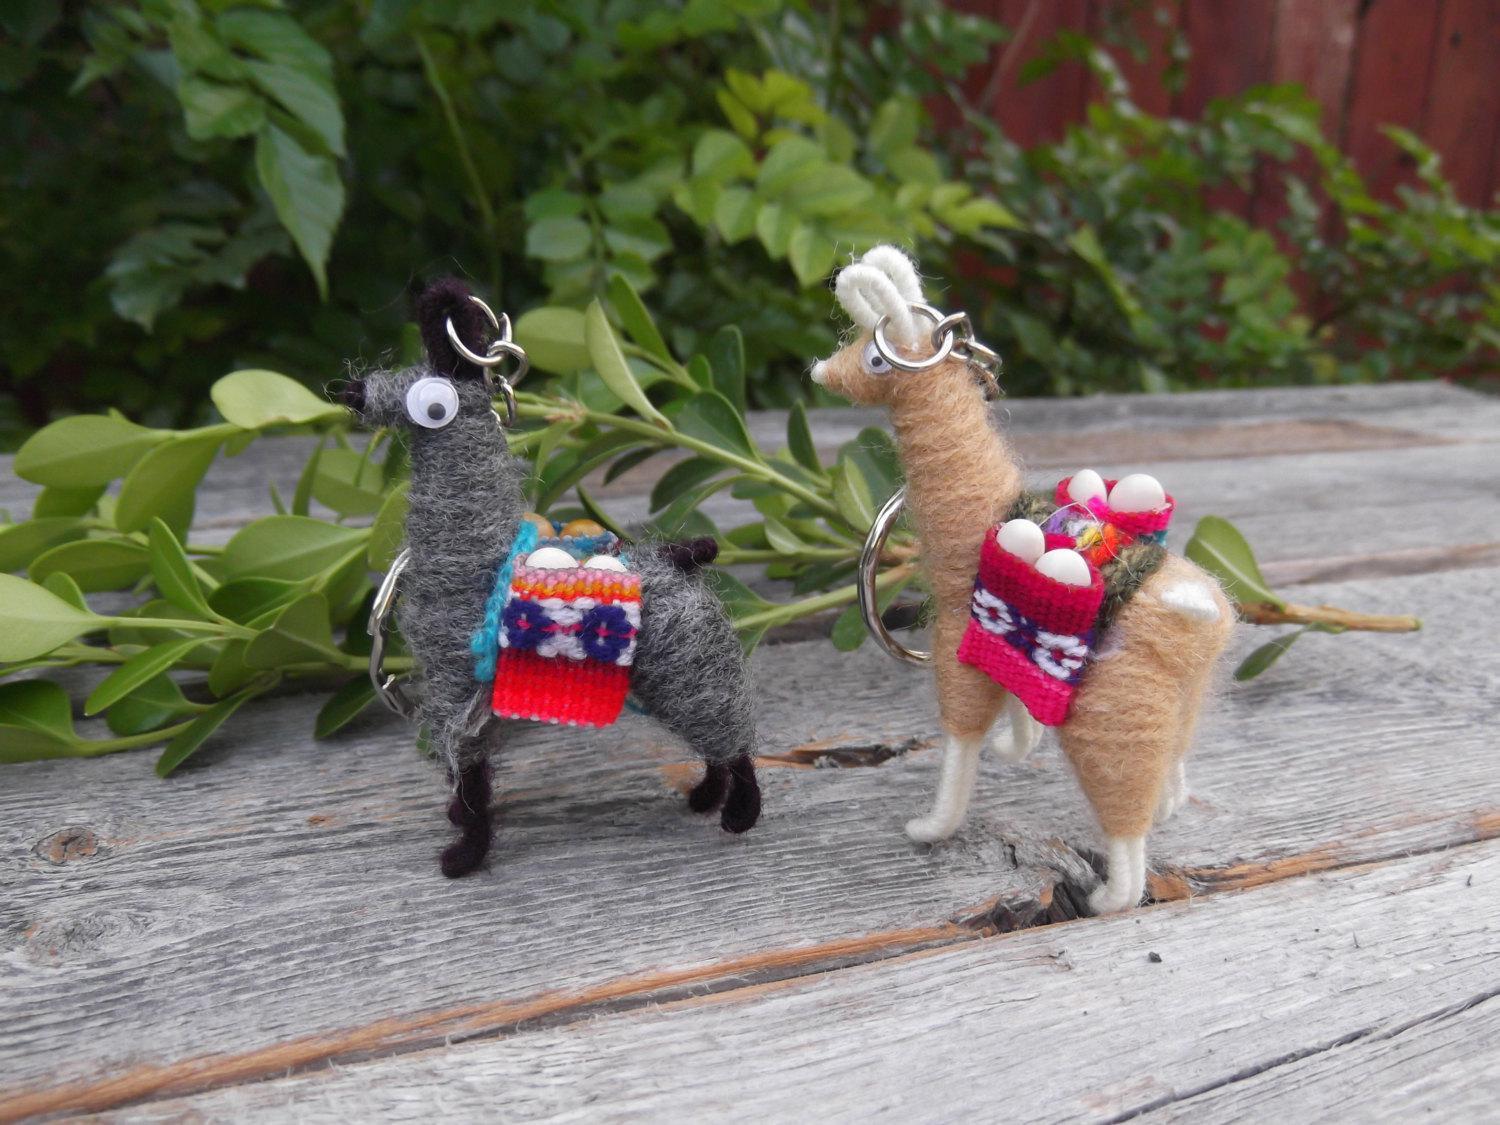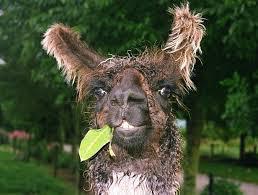The first image is the image on the left, the second image is the image on the right. Evaluate the accuracy of this statement regarding the images: "Red material hangs from the ears of the animal in the image on the left.". Is it true? Answer yes or no. No. The first image is the image on the left, the second image is the image on the right. Evaluate the accuracy of this statement regarding the images: "Each image includes one foreground llama wearing a pair of colorful tassles somewhere on its head.". Is it true? Answer yes or no. No. 